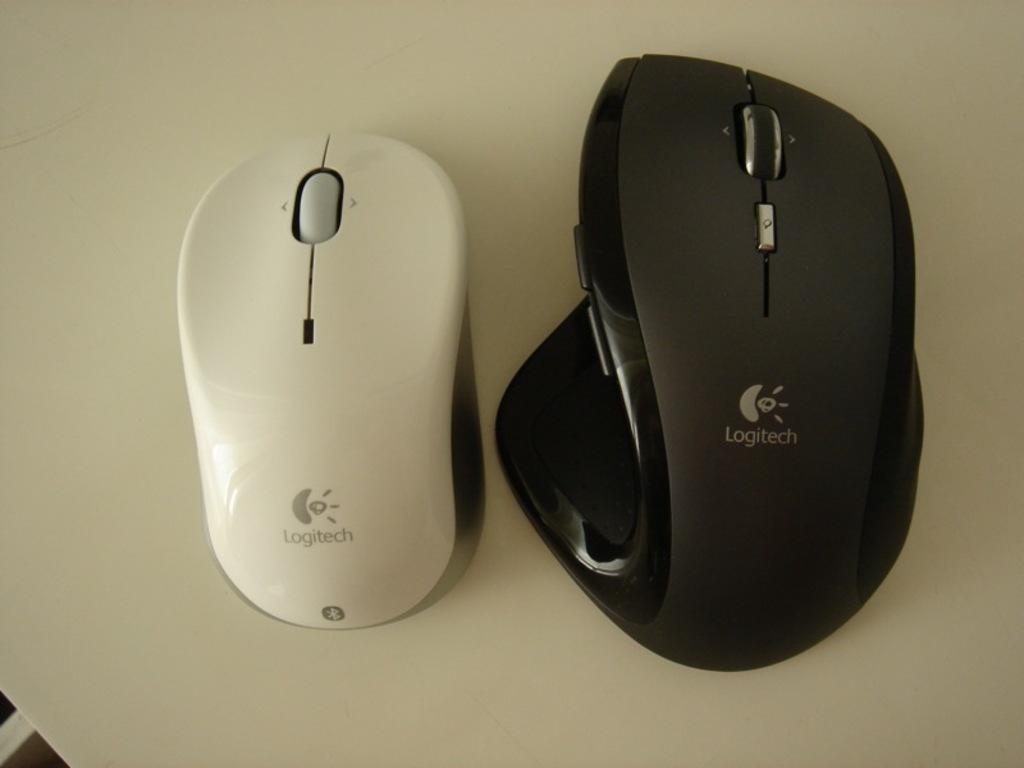How many mice are present in the image? There are two mice in the image. What colors are the mice? One mouse is white in the white in color, and the other is black in color. What is written on the mice? There is text on the mice. What is the background of the image? The mice are on a white surface. How many children are playing with the mice in the image? There are no children present in the image; it only features the two mice. What advice does the grandfather give about the mice in the image? There is no grandfather present in the image, and therefore no advice can be given. 